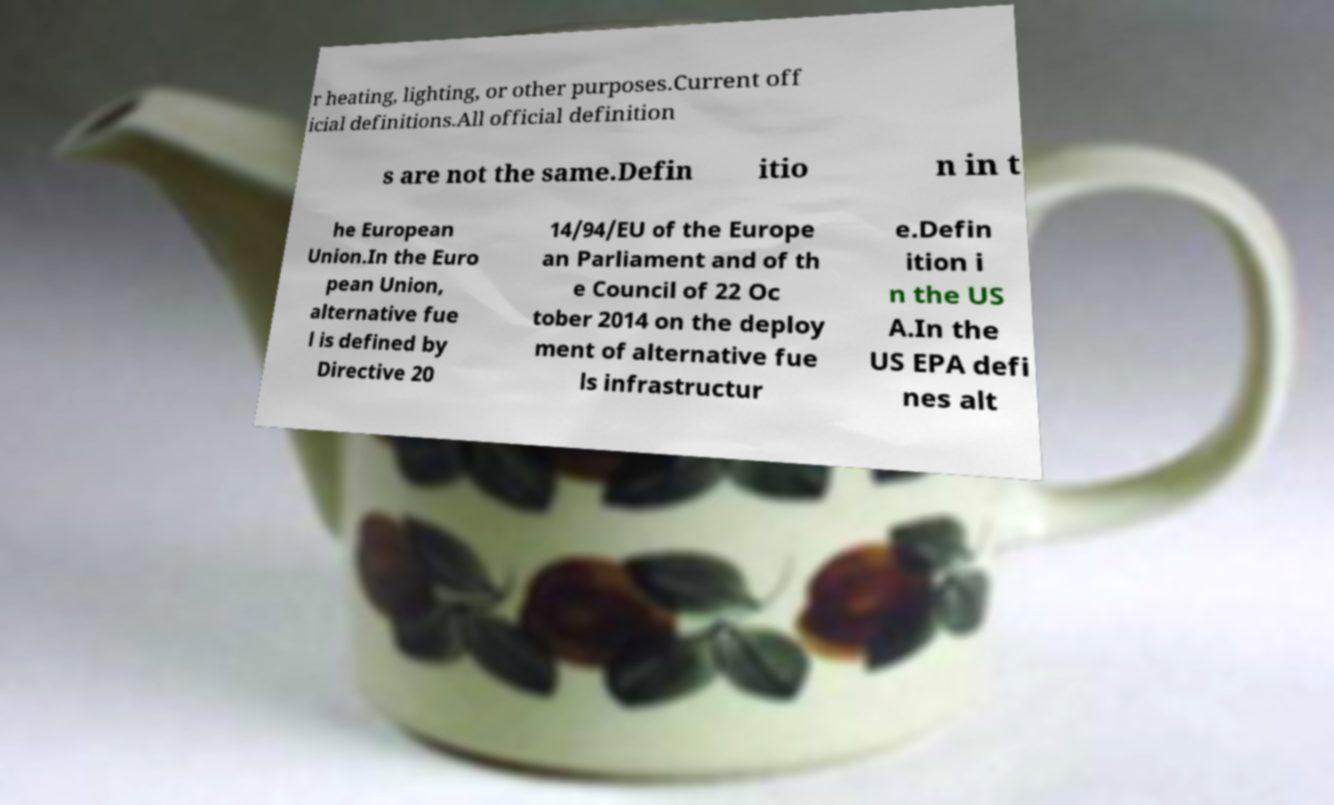Could you extract and type out the text from this image? r heating, lighting, or other purposes.Current off icial definitions.All official definition s are not the same.Defin itio n in t he European Union.In the Euro pean Union, alternative fue l is defined by Directive 20 14/94/EU of the Europe an Parliament and of th e Council of 22 Oc tober 2014 on the deploy ment of alternative fue ls infrastructur e.Defin ition i n the US A.In the US EPA defi nes alt 